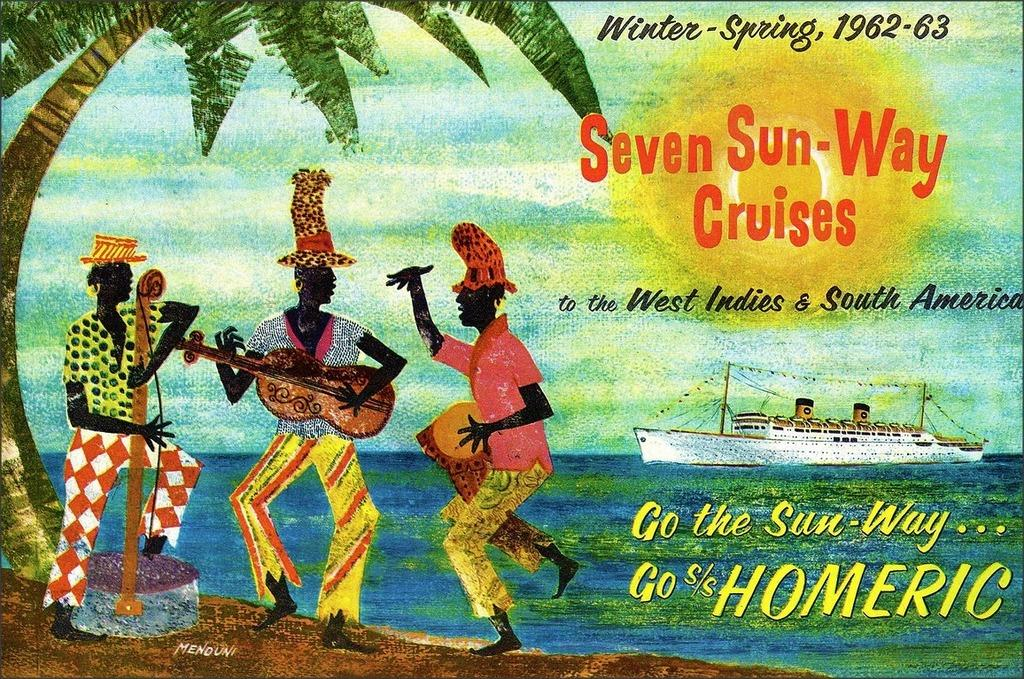<image>
Write a terse but informative summary of the picture. A very old advertising poster for seven sun-way cruises depicts an idyllic carribbean setting. 